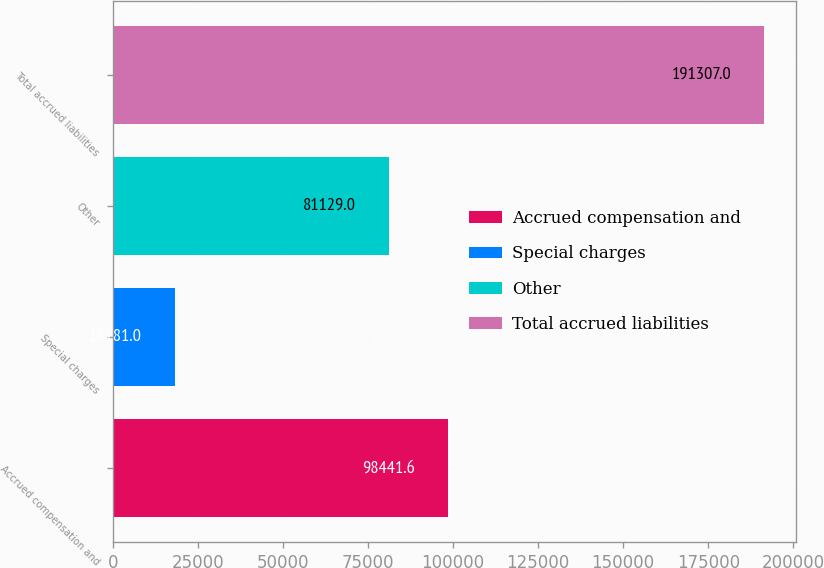Convert chart to OTSL. <chart><loc_0><loc_0><loc_500><loc_500><bar_chart><fcel>Accrued compensation and<fcel>Special charges<fcel>Other<fcel>Total accrued liabilities<nl><fcel>98441.6<fcel>18181<fcel>81129<fcel>191307<nl></chart> 